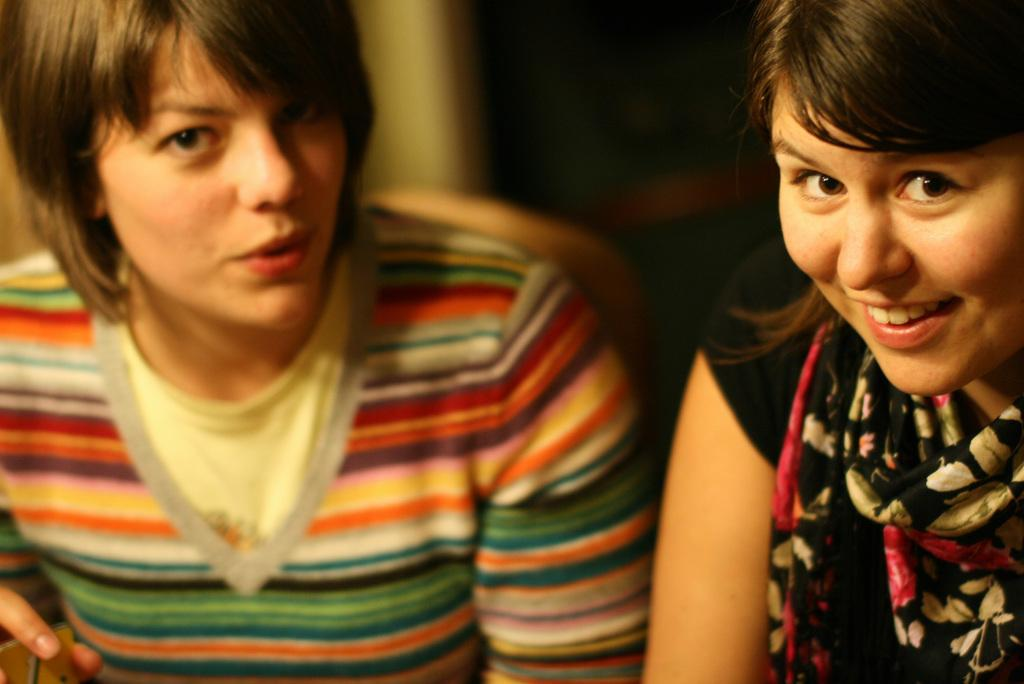How many people are in the image? There are two persons in the image. What is one of the persons doing in the image? One of the persons is holding an object. What type of nut is being used to plough the field in the image? There is no nut or plough present in the image. What record is being played by the person holding the object in the image? There is no record or object related to playing music in the image. 